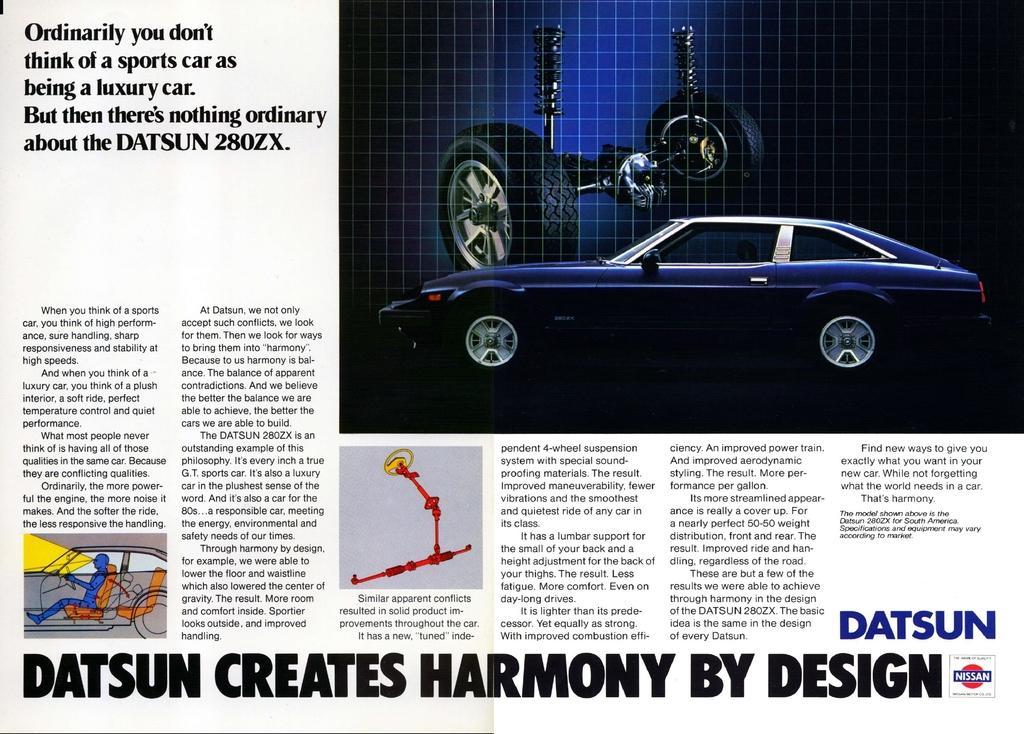How would you summarize this image in a sentence or two? In this image we can see there is an image of a car, beside and below this image there is some text and other images. 